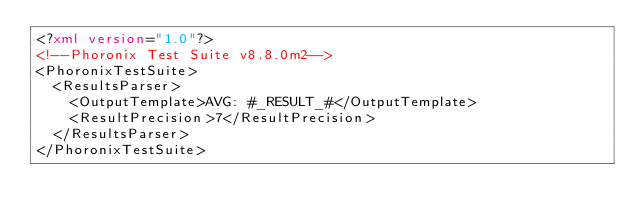Convert code to text. <code><loc_0><loc_0><loc_500><loc_500><_XML_><?xml version="1.0"?>
<!--Phoronix Test Suite v8.8.0m2-->
<PhoronixTestSuite>
  <ResultsParser>
    <OutputTemplate>AVG: #_RESULT_#</OutputTemplate>
    <ResultPrecision>7</ResultPrecision>
  </ResultsParser>
</PhoronixTestSuite>
</code> 